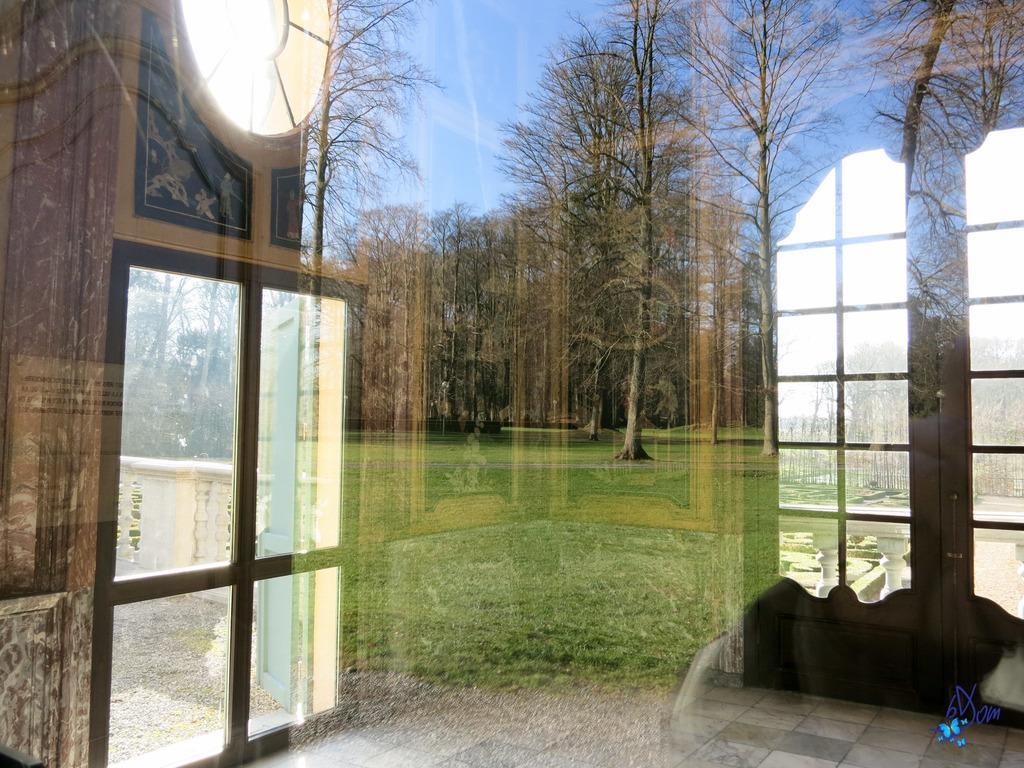Please provide a concise description of this image. In this picture I can see a transparent glass, there is a wall with doors and a window, there is a reflection of grass, trees and the sky on the transparent glass, and there is a watermark on the image. 